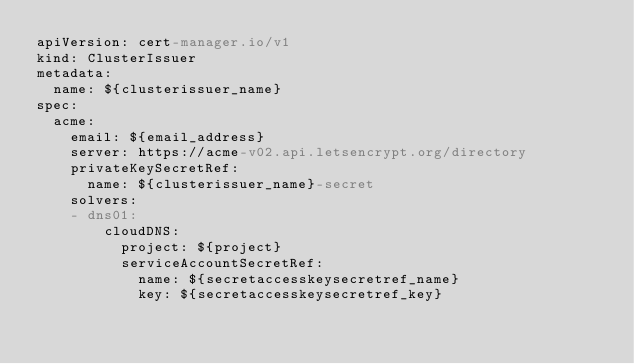<code> <loc_0><loc_0><loc_500><loc_500><_YAML_>apiVersion: cert-manager.io/v1
kind: ClusterIssuer
metadata:
  name: ${clusterissuer_name}
spec:
  acme:
    email: ${email_address}
    server: https://acme-v02.api.letsencrypt.org/directory
    privateKeySecretRef:
      name: ${clusterissuer_name}-secret
    solvers:
    - dns01:
        cloudDNS:
          project: ${project}
          serviceAccountSecretRef:
            name: ${secretaccesskeysecretref_name}
            key: ${secretaccesskeysecretref_key}</code> 